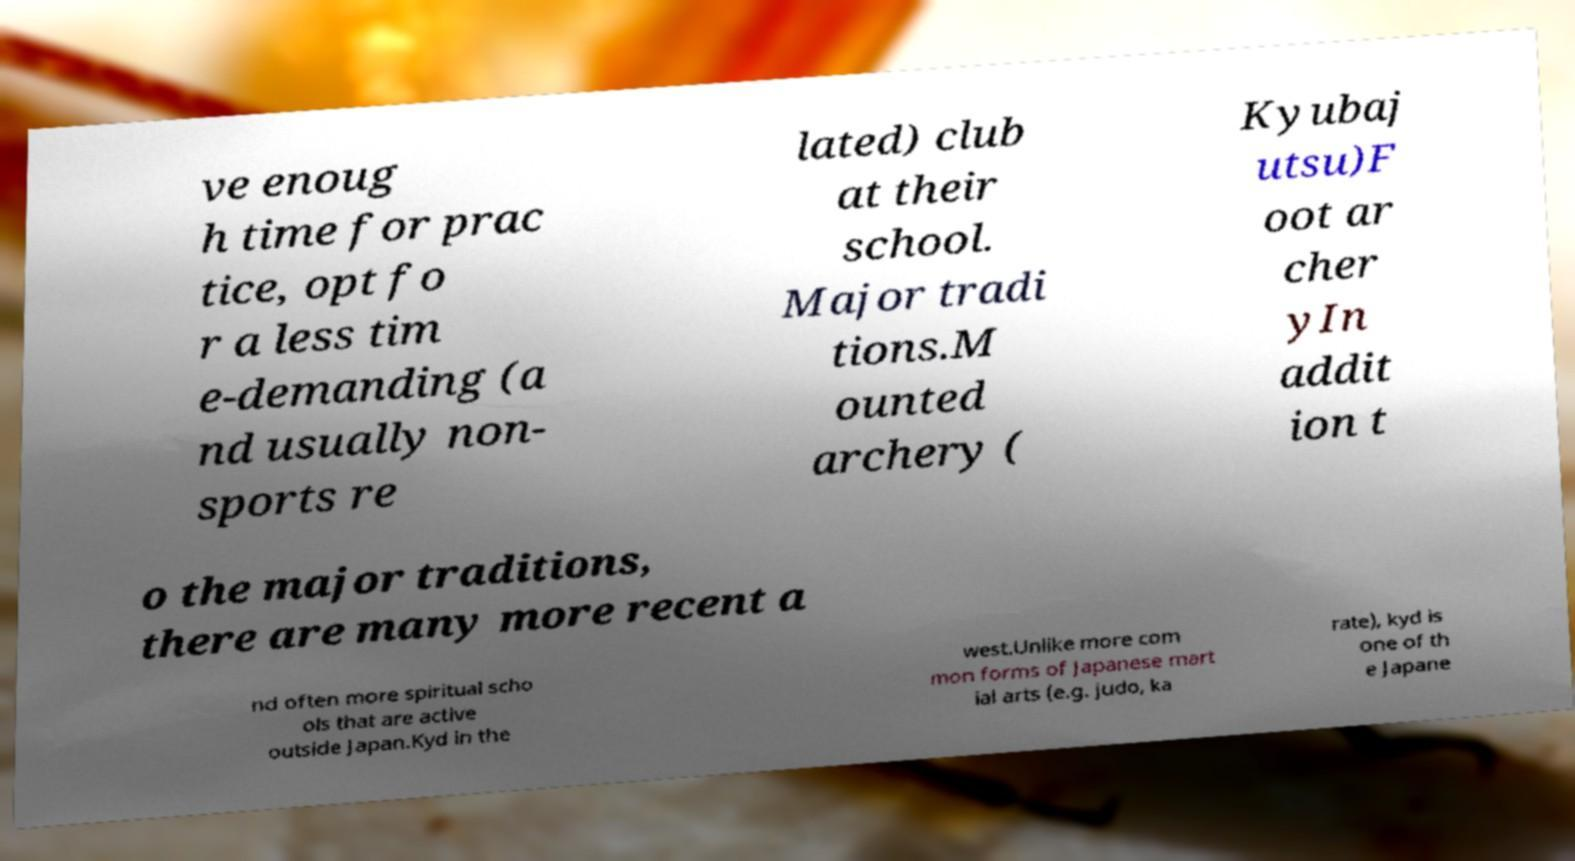What messages or text are displayed in this image? I need them in a readable, typed format. ve enoug h time for prac tice, opt fo r a less tim e-demanding (a nd usually non- sports re lated) club at their school. Major tradi tions.M ounted archery ( Kyubaj utsu)F oot ar cher yIn addit ion t o the major traditions, there are many more recent a nd often more spiritual scho ols that are active outside Japan.Kyd in the west.Unlike more com mon forms of Japanese mart ial arts (e.g. judo, ka rate), kyd is one of th e Japane 